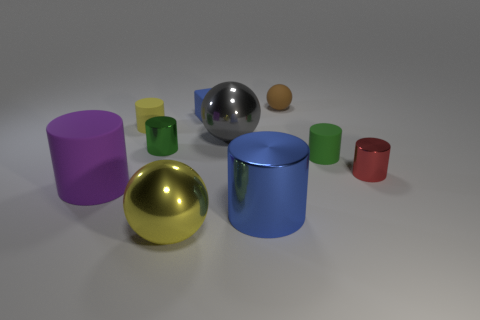Subtract all small rubber cylinders. How many cylinders are left? 4 Subtract all green cylinders. How many cylinders are left? 4 Subtract all blue cylinders. Subtract all purple blocks. How many cylinders are left? 5 Subtract all blocks. How many objects are left? 9 Subtract 0 brown blocks. How many objects are left? 10 Subtract all small green shiny things. Subtract all small cubes. How many objects are left? 8 Add 8 big blue metal objects. How many big blue metal objects are left? 9 Add 9 big blue metal cylinders. How many big blue metal cylinders exist? 10 